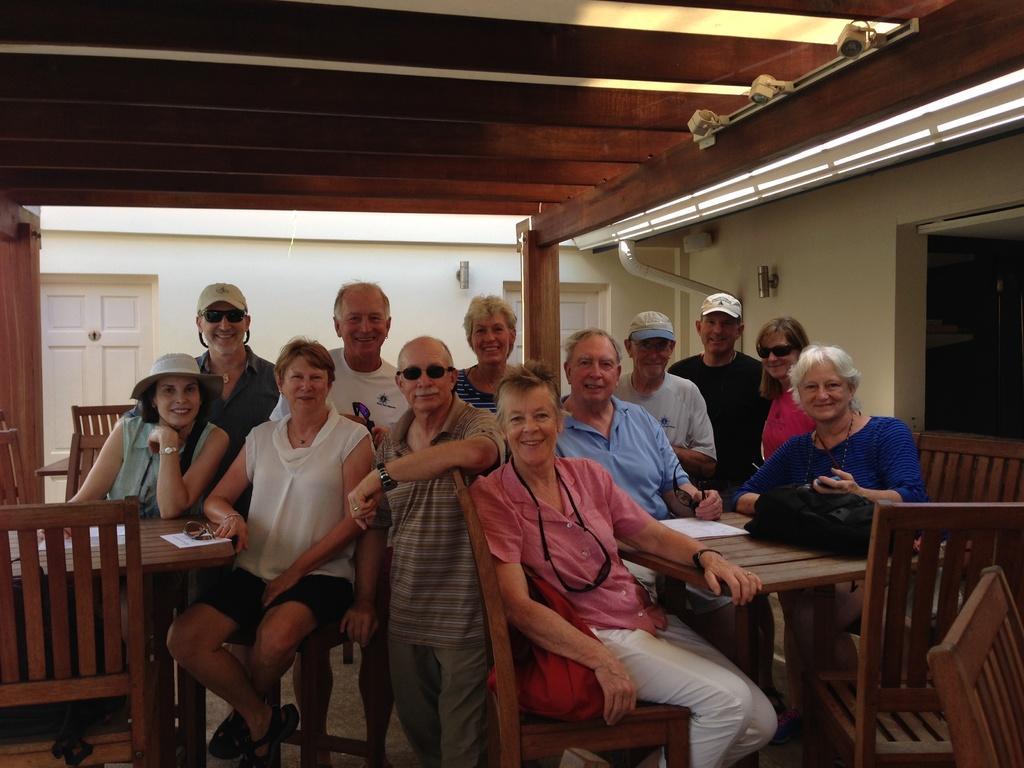How would you summarize this image in a sentence or two? in a room there are 2 wooden tables. and wooden chairs. 4 people are sitting on the chairs and other people are standing behind them. the person at the front is wearing pink shirt, white pant and a red bag is kept on her chair. right to her a person is sitting wearing a blue shirt. in front of her there is a black bag on the table. at the left a person is sitting wearing white shirt and a hat. left to her a person is sitting wearing green shirt and a hat. on the table there is a paper and goggles. behind them 6 people are standing. at the back there is a white wall and 2 white doors. at the right there is a wall and open at the front. 